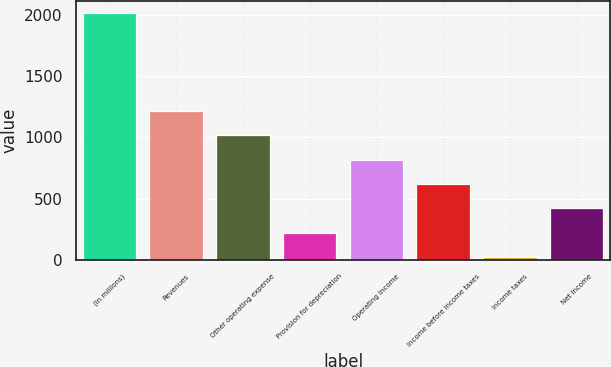<chart> <loc_0><loc_0><loc_500><loc_500><bar_chart><fcel>(In millions)<fcel>Revenues<fcel>Other operating expense<fcel>Provision for depreciation<fcel>Operating Income<fcel>Income before income taxes<fcel>Income taxes<fcel>Net Income<nl><fcel>2010<fcel>1215.6<fcel>1017<fcel>222.6<fcel>818.4<fcel>619.8<fcel>24<fcel>421.2<nl></chart> 